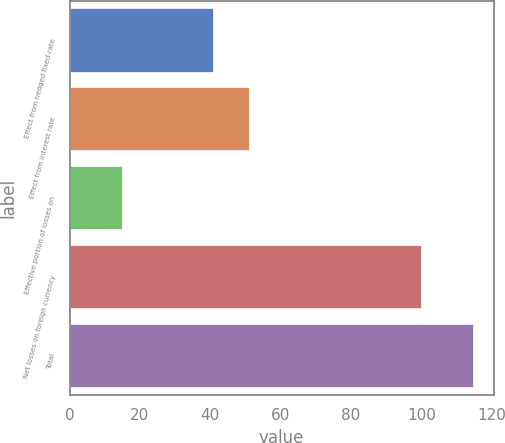Convert chart to OTSL. <chart><loc_0><loc_0><loc_500><loc_500><bar_chart><fcel>Effect from hedged fixed-rate<fcel>Effect from interest rate<fcel>Effective portion of losses on<fcel>Net losses on foreign currency<fcel>Total<nl><fcel>40.9<fcel>50.9<fcel>14.8<fcel>100<fcel>114.8<nl></chart> 